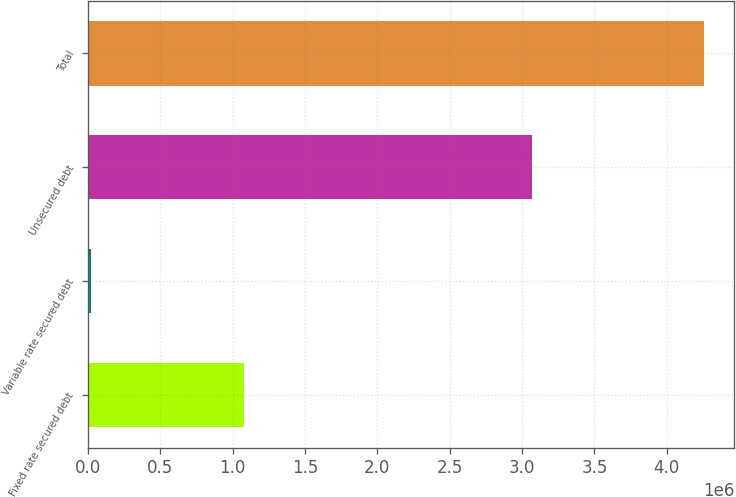Convert chart to OTSL. <chart><loc_0><loc_0><loc_500><loc_500><bar_chart><fcel>Fixed rate secured debt<fcel>Variable rate secured debt<fcel>Unsecured debt<fcel>Total<nl><fcel>1.08104e+06<fcel>19089<fcel>3.06625e+06<fcel>4.25438e+06<nl></chart> 